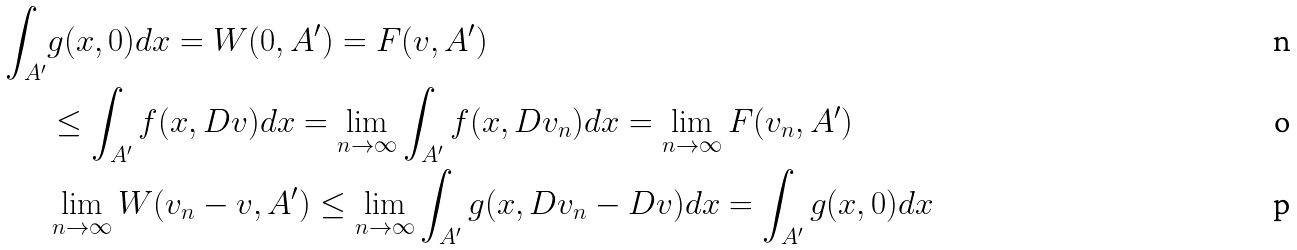Convert formula to latex. <formula><loc_0><loc_0><loc_500><loc_500>\int _ { A ^ { \prime } } & g ( x , 0 ) d x = W ( 0 , A ^ { \prime } ) = F ( v , A ^ { \prime } ) \\ & \leq \int _ { A ^ { \prime } } f ( x , D v ) d x = \lim _ { n \rightarrow \infty } \int _ { A ^ { \prime } } f ( x , D v _ { n } ) d x = \lim _ { n \rightarrow \infty } F ( v _ { n } , A ^ { \prime } ) \\ & \lim _ { n \rightarrow \infty } W ( v _ { n } - v , A ^ { \prime } ) \leq \lim _ { n \rightarrow \infty } \int _ { A ^ { \prime } } g ( x , D v _ { n } - D v ) d x = \int _ { A ^ { \prime } } g ( x , 0 ) d x</formula> 